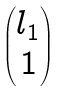Convert formula to latex. <formula><loc_0><loc_0><loc_500><loc_500>\begin{pmatrix} l _ { 1 } \\ 1 \end{pmatrix}</formula> 